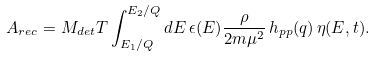<formula> <loc_0><loc_0><loc_500><loc_500>A _ { r e c } = M _ { d e t } T \int _ { E _ { 1 } / Q } ^ { E _ { 2 } / Q } d E \, \epsilon ( E ) \frac { \rho } { 2 m \mu ^ { 2 } } \, h _ { p p } ( q ) \, \eta ( E , t ) .</formula> 